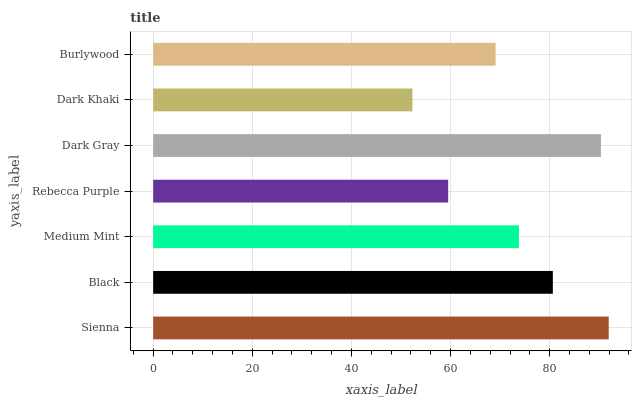Is Dark Khaki the minimum?
Answer yes or no. Yes. Is Sienna the maximum?
Answer yes or no. Yes. Is Black the minimum?
Answer yes or no. No. Is Black the maximum?
Answer yes or no. No. Is Sienna greater than Black?
Answer yes or no. Yes. Is Black less than Sienna?
Answer yes or no. Yes. Is Black greater than Sienna?
Answer yes or no. No. Is Sienna less than Black?
Answer yes or no. No. Is Medium Mint the high median?
Answer yes or no. Yes. Is Medium Mint the low median?
Answer yes or no. Yes. Is Dark Khaki the high median?
Answer yes or no. No. Is Black the low median?
Answer yes or no. No. 